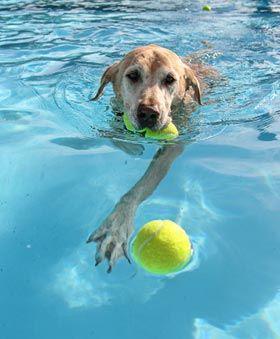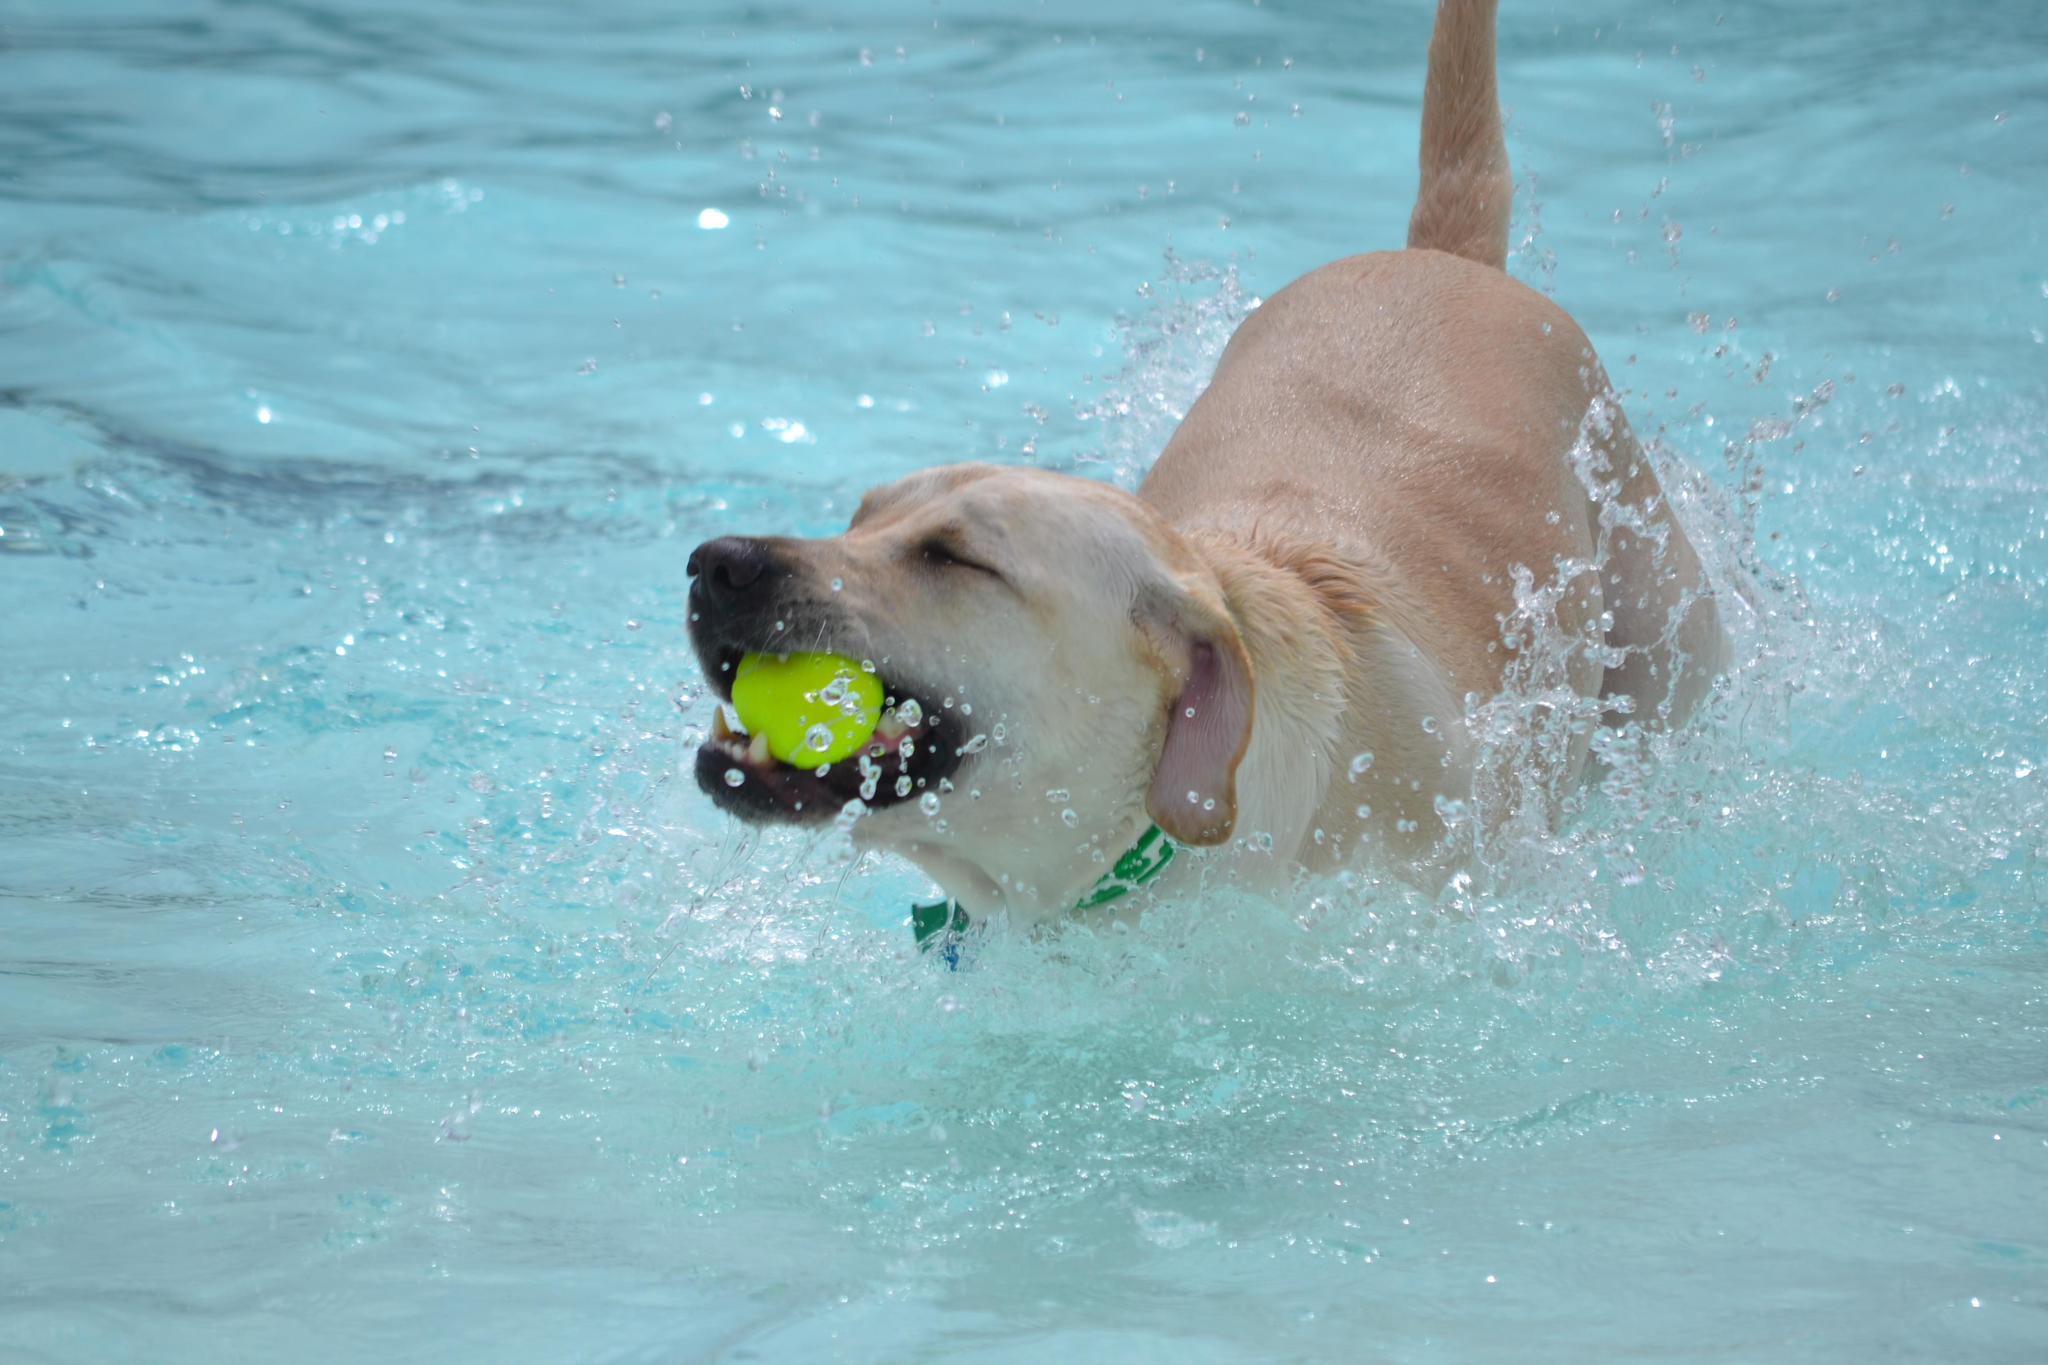The first image is the image on the left, the second image is the image on the right. For the images displayed, is the sentence "The dog in the image on the left is swimming with a rod in its mouth." factually correct? Answer yes or no. No. The first image is the image on the left, the second image is the image on the right. Considering the images on both sides, is "An image shows a swimming dog carrying a stick-shaped object in its mouth." valid? Answer yes or no. No. 